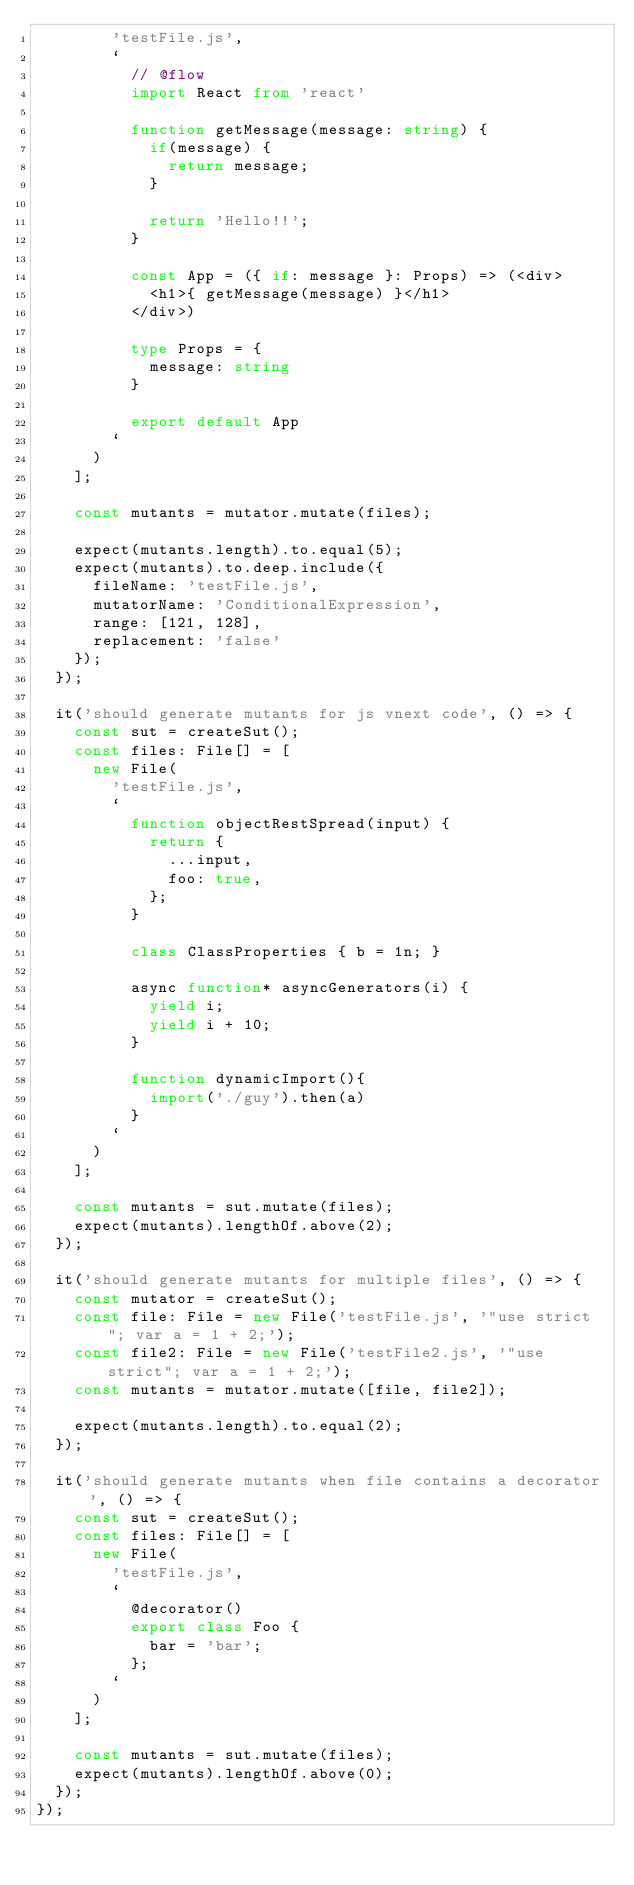<code> <loc_0><loc_0><loc_500><loc_500><_TypeScript_>        'testFile.js',
        `
          // @flow
          import React from 'react'

          function getMessage(message: string) {
            if(message) {
              return message;
            }

            return 'Hello!!';
          }

          const App = ({ if: message }: Props) => (<div>
            <h1>{ getMessage(message) }</h1>
          </div>)

          type Props = {
            message: string
          }

          export default App
        `
      )
    ];

    const mutants = mutator.mutate(files);

    expect(mutants.length).to.equal(5);
    expect(mutants).to.deep.include({
      fileName: 'testFile.js',
      mutatorName: 'ConditionalExpression',
      range: [121, 128],
      replacement: 'false'
    });
  });

  it('should generate mutants for js vnext code', () => {
    const sut = createSut();
    const files: File[] = [
      new File(
        'testFile.js',
        `
          function objectRestSpread(input) {
            return {
              ...input,
              foo: true,
            };
          }

          class ClassProperties { b = 1n; }

          async function* asyncGenerators(i) {
            yield i;
            yield i + 10;
          }

          function dynamicImport(){
            import('./guy').then(a)
          }
        `
      )
    ];

    const mutants = sut.mutate(files);
    expect(mutants).lengthOf.above(2);
  });

  it('should generate mutants for multiple files', () => {
    const mutator = createSut();
    const file: File = new File('testFile.js', '"use strict"; var a = 1 + 2;');
    const file2: File = new File('testFile2.js', '"use strict"; var a = 1 + 2;');
    const mutants = mutator.mutate([file, file2]);

    expect(mutants.length).to.equal(2);
  });

  it('should generate mutants when file contains a decorator', () => {
    const sut = createSut();
    const files: File[] = [
      new File(
        'testFile.js',
        `
          @decorator()
          export class Foo {
            bar = 'bar';
          };
        `
      )
    ];

    const mutants = sut.mutate(files);
    expect(mutants).lengthOf.above(0);
  });
});
</code> 